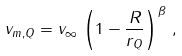Convert formula to latex. <formula><loc_0><loc_0><loc_500><loc_500>v _ { m , Q } = v _ { \infty } \, \left ( 1 - \frac { R } { r _ { Q } } \right ) ^ { \beta } \, ,</formula> 